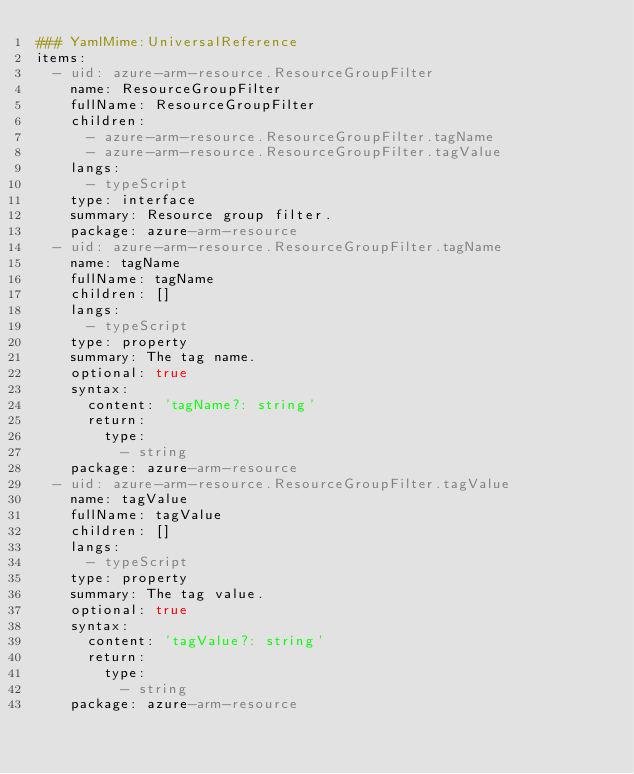Convert code to text. <code><loc_0><loc_0><loc_500><loc_500><_YAML_>### YamlMime:UniversalReference
items:
  - uid: azure-arm-resource.ResourceGroupFilter
    name: ResourceGroupFilter
    fullName: ResourceGroupFilter
    children:
      - azure-arm-resource.ResourceGroupFilter.tagName
      - azure-arm-resource.ResourceGroupFilter.tagValue
    langs:
      - typeScript
    type: interface
    summary: Resource group filter.
    package: azure-arm-resource
  - uid: azure-arm-resource.ResourceGroupFilter.tagName
    name: tagName
    fullName: tagName
    children: []
    langs:
      - typeScript
    type: property
    summary: The tag name.
    optional: true
    syntax:
      content: 'tagName?: string'
      return:
        type:
          - string
    package: azure-arm-resource
  - uid: azure-arm-resource.ResourceGroupFilter.tagValue
    name: tagValue
    fullName: tagValue
    children: []
    langs:
      - typeScript
    type: property
    summary: The tag value.
    optional: true
    syntax:
      content: 'tagValue?: string'
      return:
        type:
          - string
    package: azure-arm-resource
</code> 